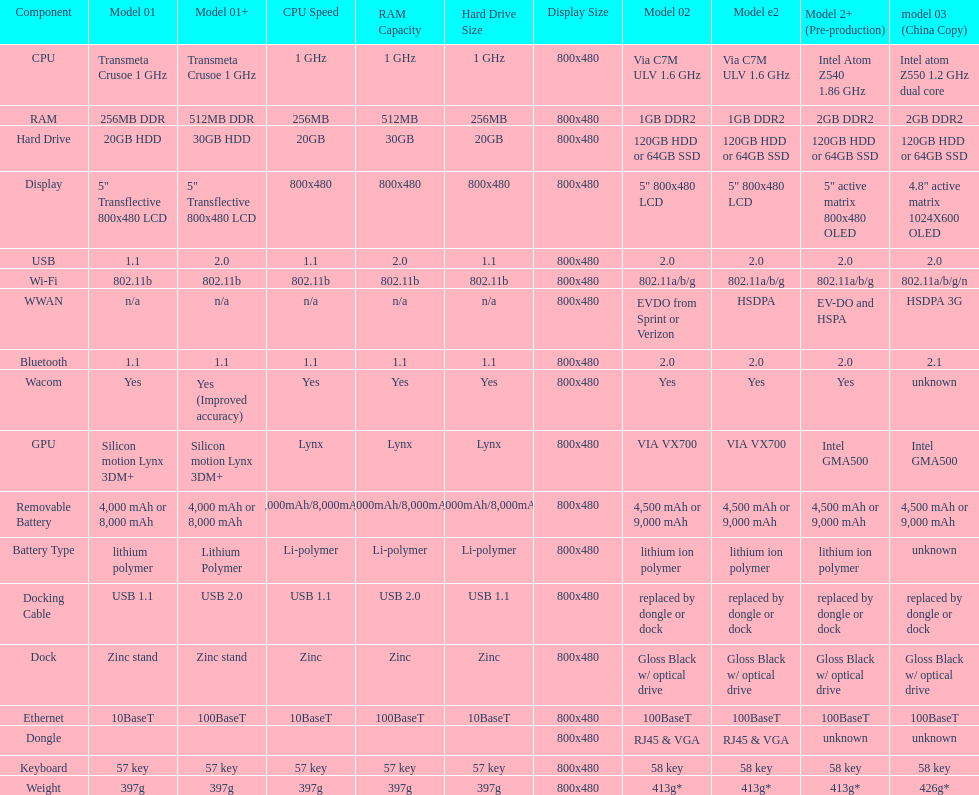Could you help me parse every detail presented in this table? {'header': ['Component', 'Model 01', 'Model 01+', 'CPU Speed', 'RAM Capacity', 'Hard Drive Size', 'Display Size', 'Model 02', 'Model e2', 'Model 2+ (Pre-production)', 'model 03 (China Copy)'], 'rows': [['CPU', 'Transmeta Crusoe 1\xa0GHz', 'Transmeta Crusoe 1\xa0GHz', '1 GHz', '1 GHz', '1 GHz', '800x480', 'Via C7M ULV 1.6\xa0GHz', 'Via C7M ULV 1.6\xa0GHz', 'Intel Atom Z540 1.86\xa0GHz', 'Intel atom Z550 1.2\xa0GHz dual core'], ['RAM', '256MB DDR', '512MB DDR', '256MB', '512MB', '256MB', '800x480', '1GB DDR2', '1GB DDR2', '2GB DDR2', '2GB DDR2'], ['Hard Drive', '20GB HDD', '30GB HDD', '20GB', '30GB', '20GB', '800x480', '120GB HDD or 64GB SSD', '120GB HDD or 64GB SSD', '120GB HDD or 64GB SSD', '120GB HDD or 64GB SSD'], ['Display', '5" Transflective 800x480 LCD', '5" Transflective 800x480 LCD', '800x480', '800x480', '800x480', '800x480', '5" 800x480 LCD', '5" 800x480 LCD', '5" active matrix 800x480 OLED', '4.8" active matrix 1024X600 OLED'], ['USB', '1.1', '2.0', '1.1', '2.0', '1.1', '800x480', '2.0', '2.0', '2.0', '2.0'], ['Wi-Fi', '802.11b', '802.11b', '802.11b', '802.11b', '802.11b', '800x480', '802.11a/b/g', '802.11a/b/g', '802.11a/b/g', '802.11a/b/g/n'], ['WWAN', 'n/a', 'n/a', 'n/a', 'n/a', 'n/a', '800x480', 'EVDO from Sprint or Verizon', 'HSDPA', 'EV-DO and HSPA', 'HSDPA 3G'], ['Bluetooth', '1.1', '1.1', '1.1', '1.1', '1.1', '800x480', '2.0', '2.0', '2.0', '2.1'], ['Wacom', 'Yes', 'Yes (Improved accuracy)', 'Yes', 'Yes', 'Yes', '800x480', 'Yes', 'Yes', 'Yes', 'unknown'], ['GPU', 'Silicon motion Lynx 3DM+', 'Silicon motion Lynx 3DM+', 'Lynx', 'Lynx', 'Lynx', '800x480', 'VIA VX700', 'VIA VX700', 'Intel GMA500', 'Intel GMA500'], ['Removable Battery', '4,000 mAh or 8,000 mAh', '4,000 mAh or 8,000 mAh', '4,000mAh/8,000mAh', '4,000mAh/8,000mAh', '4,000mAh/8,000mAh', '800x480', '4,500 mAh or 9,000 mAh', '4,500 mAh or 9,000 mAh', '4,500 mAh or 9,000 mAh', '4,500 mAh or 9,000 mAh'], ['Battery Type', 'lithium polymer', 'Lithium Polymer', 'Li-polymer', 'Li-polymer', 'Li-polymer', '800x480', 'lithium ion polymer', 'lithium ion polymer', 'lithium ion polymer', 'unknown'], ['Docking Cable', 'USB 1.1', 'USB 2.0', 'USB 1.1', 'USB 2.0', 'USB 1.1', '800x480', 'replaced by dongle or dock', 'replaced by dongle or dock', 'replaced by dongle or dock', 'replaced by dongle or dock'], ['Dock', 'Zinc stand', 'Zinc stand', 'Zinc', 'Zinc', 'Zinc', '800x480', 'Gloss Black w/ optical drive', 'Gloss Black w/ optical drive', 'Gloss Black w/ optical drive', 'Gloss Black w/ optical drive'], ['Ethernet', '10BaseT', '100BaseT', '10BaseT', '100BaseT', '10BaseT', '800x480', '100BaseT', '100BaseT', '100BaseT', '100BaseT'], ['Dongle', '', '', '', '', '', '800x480', 'RJ45 & VGA', 'RJ45 & VGA', 'unknown', 'unknown'], ['Keyboard', '57 key', '57 key', '57 key', '57 key', '57 key', '800x480', '58 key', '58 key', '58 key', '58 key'], ['Weight', '397g', '397g', '397g', '397g', '397g', '800x480', '413g*', '413g*', '413g*', '426g*']]} How many models on average come with usb 5. 